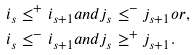<formula> <loc_0><loc_0><loc_500><loc_500>i _ { s } \leq ^ { + } i _ { s + 1 } & a n d j _ { s } \leq ^ { - } j _ { s + 1 } o r , \\ i _ { s } \leq ^ { - } i _ { s + 1 } & a n d j _ { s } \geq ^ { + } j _ { s + 1 } .</formula> 